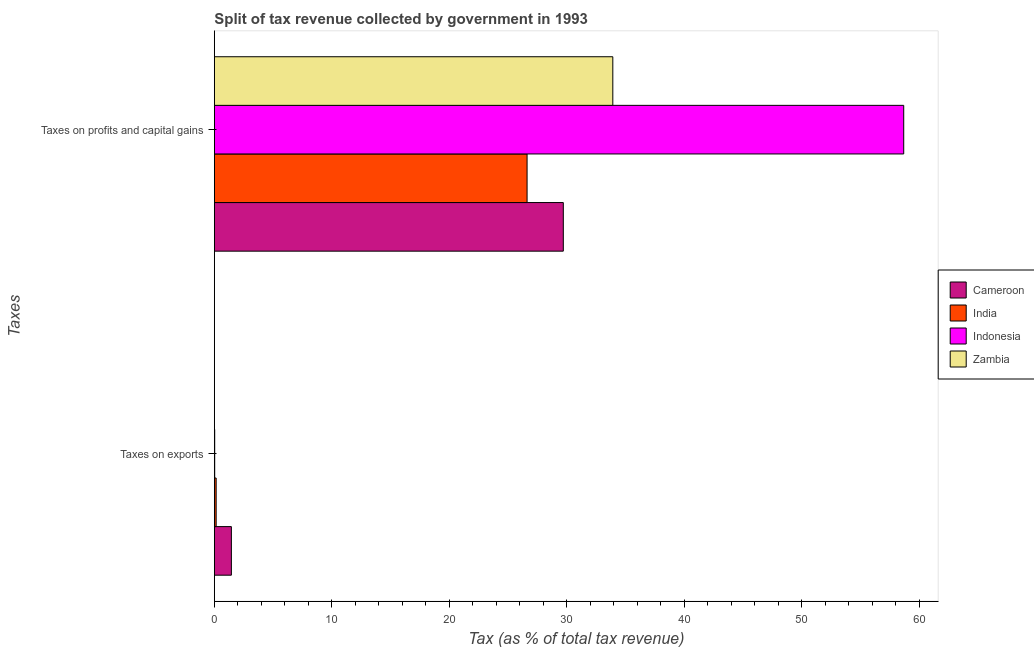How many different coloured bars are there?
Offer a terse response. 4. How many groups of bars are there?
Ensure brevity in your answer.  2. Are the number of bars per tick equal to the number of legend labels?
Make the answer very short. Yes. How many bars are there on the 2nd tick from the bottom?
Give a very brief answer. 4. What is the label of the 1st group of bars from the top?
Provide a succinct answer. Taxes on profits and capital gains. What is the percentage of revenue obtained from taxes on exports in India?
Your answer should be very brief. 0.15. Across all countries, what is the maximum percentage of revenue obtained from taxes on profits and capital gains?
Ensure brevity in your answer.  58.68. Across all countries, what is the minimum percentage of revenue obtained from taxes on profits and capital gains?
Your answer should be compact. 26.62. In which country was the percentage of revenue obtained from taxes on exports maximum?
Your response must be concise. Cameroon. What is the total percentage of revenue obtained from taxes on exports in the graph?
Ensure brevity in your answer.  1.64. What is the difference between the percentage of revenue obtained from taxes on profits and capital gains in India and that in Indonesia?
Make the answer very short. -32.06. What is the difference between the percentage of revenue obtained from taxes on profits and capital gains in India and the percentage of revenue obtained from taxes on exports in Zambia?
Your answer should be very brief. 26.61. What is the average percentage of revenue obtained from taxes on profits and capital gains per country?
Make the answer very short. 37.23. What is the difference between the percentage of revenue obtained from taxes on profits and capital gains and percentage of revenue obtained from taxes on exports in Zambia?
Your answer should be very brief. 33.91. What is the ratio of the percentage of revenue obtained from taxes on exports in Cameroon to that in India?
Make the answer very short. 9.42. Is the percentage of revenue obtained from taxes on exports in Cameroon less than that in Zambia?
Offer a very short reply. No. In how many countries, is the percentage of revenue obtained from taxes on exports greater than the average percentage of revenue obtained from taxes on exports taken over all countries?
Make the answer very short. 1. How many bars are there?
Ensure brevity in your answer.  8. What is the difference between two consecutive major ticks on the X-axis?
Offer a terse response. 10. Does the graph contain grids?
Make the answer very short. No. How many legend labels are there?
Make the answer very short. 4. How are the legend labels stacked?
Your answer should be compact. Vertical. What is the title of the graph?
Ensure brevity in your answer.  Split of tax revenue collected by government in 1993. What is the label or title of the X-axis?
Offer a very short reply. Tax (as % of total tax revenue). What is the label or title of the Y-axis?
Keep it short and to the point. Taxes. What is the Tax (as % of total tax revenue) of Cameroon in Taxes on exports?
Offer a very short reply. 1.45. What is the Tax (as % of total tax revenue) in India in Taxes on exports?
Offer a terse response. 0.15. What is the Tax (as % of total tax revenue) of Indonesia in Taxes on exports?
Your response must be concise. 0.03. What is the Tax (as % of total tax revenue) of Zambia in Taxes on exports?
Offer a very short reply. 0.01. What is the Tax (as % of total tax revenue) of Cameroon in Taxes on profits and capital gains?
Keep it short and to the point. 29.7. What is the Tax (as % of total tax revenue) of India in Taxes on profits and capital gains?
Your answer should be compact. 26.62. What is the Tax (as % of total tax revenue) of Indonesia in Taxes on profits and capital gains?
Provide a succinct answer. 58.68. What is the Tax (as % of total tax revenue) in Zambia in Taxes on profits and capital gains?
Your answer should be compact. 33.92. Across all Taxes, what is the maximum Tax (as % of total tax revenue) of Cameroon?
Make the answer very short. 29.7. Across all Taxes, what is the maximum Tax (as % of total tax revenue) of India?
Ensure brevity in your answer.  26.62. Across all Taxes, what is the maximum Tax (as % of total tax revenue) in Indonesia?
Your answer should be compact. 58.68. Across all Taxes, what is the maximum Tax (as % of total tax revenue) in Zambia?
Make the answer very short. 33.92. Across all Taxes, what is the minimum Tax (as % of total tax revenue) in Cameroon?
Provide a short and direct response. 1.45. Across all Taxes, what is the minimum Tax (as % of total tax revenue) in India?
Ensure brevity in your answer.  0.15. Across all Taxes, what is the minimum Tax (as % of total tax revenue) of Indonesia?
Provide a succinct answer. 0.03. Across all Taxes, what is the minimum Tax (as % of total tax revenue) of Zambia?
Offer a very short reply. 0.01. What is the total Tax (as % of total tax revenue) of Cameroon in the graph?
Provide a succinct answer. 31.15. What is the total Tax (as % of total tax revenue) in India in the graph?
Give a very brief answer. 26.77. What is the total Tax (as % of total tax revenue) in Indonesia in the graph?
Keep it short and to the point. 58.71. What is the total Tax (as % of total tax revenue) of Zambia in the graph?
Make the answer very short. 33.92. What is the difference between the Tax (as % of total tax revenue) of Cameroon in Taxes on exports and that in Taxes on profits and capital gains?
Provide a short and direct response. -28.25. What is the difference between the Tax (as % of total tax revenue) of India in Taxes on exports and that in Taxes on profits and capital gains?
Keep it short and to the point. -26.47. What is the difference between the Tax (as % of total tax revenue) in Indonesia in Taxes on exports and that in Taxes on profits and capital gains?
Give a very brief answer. -58.65. What is the difference between the Tax (as % of total tax revenue) of Zambia in Taxes on exports and that in Taxes on profits and capital gains?
Your answer should be very brief. -33.91. What is the difference between the Tax (as % of total tax revenue) in Cameroon in Taxes on exports and the Tax (as % of total tax revenue) in India in Taxes on profits and capital gains?
Provide a succinct answer. -25.17. What is the difference between the Tax (as % of total tax revenue) of Cameroon in Taxes on exports and the Tax (as % of total tax revenue) of Indonesia in Taxes on profits and capital gains?
Make the answer very short. -57.23. What is the difference between the Tax (as % of total tax revenue) in Cameroon in Taxes on exports and the Tax (as % of total tax revenue) in Zambia in Taxes on profits and capital gains?
Give a very brief answer. -32.47. What is the difference between the Tax (as % of total tax revenue) of India in Taxes on exports and the Tax (as % of total tax revenue) of Indonesia in Taxes on profits and capital gains?
Your answer should be compact. -58.53. What is the difference between the Tax (as % of total tax revenue) of India in Taxes on exports and the Tax (as % of total tax revenue) of Zambia in Taxes on profits and capital gains?
Your answer should be compact. -33.76. What is the difference between the Tax (as % of total tax revenue) of Indonesia in Taxes on exports and the Tax (as % of total tax revenue) of Zambia in Taxes on profits and capital gains?
Give a very brief answer. -33.89. What is the average Tax (as % of total tax revenue) in Cameroon per Taxes?
Offer a very short reply. 15.58. What is the average Tax (as % of total tax revenue) in India per Taxes?
Your answer should be very brief. 13.39. What is the average Tax (as % of total tax revenue) of Indonesia per Taxes?
Offer a terse response. 29.35. What is the average Tax (as % of total tax revenue) of Zambia per Taxes?
Offer a terse response. 16.96. What is the difference between the Tax (as % of total tax revenue) in Cameroon and Tax (as % of total tax revenue) in India in Taxes on exports?
Your answer should be very brief. 1.3. What is the difference between the Tax (as % of total tax revenue) of Cameroon and Tax (as % of total tax revenue) of Indonesia in Taxes on exports?
Offer a terse response. 1.42. What is the difference between the Tax (as % of total tax revenue) of Cameroon and Tax (as % of total tax revenue) of Zambia in Taxes on exports?
Make the answer very short. 1.44. What is the difference between the Tax (as % of total tax revenue) of India and Tax (as % of total tax revenue) of Indonesia in Taxes on exports?
Your answer should be very brief. 0.12. What is the difference between the Tax (as % of total tax revenue) of India and Tax (as % of total tax revenue) of Zambia in Taxes on exports?
Keep it short and to the point. 0.15. What is the difference between the Tax (as % of total tax revenue) of Indonesia and Tax (as % of total tax revenue) of Zambia in Taxes on exports?
Offer a very short reply. 0.02. What is the difference between the Tax (as % of total tax revenue) in Cameroon and Tax (as % of total tax revenue) in India in Taxes on profits and capital gains?
Give a very brief answer. 3.08. What is the difference between the Tax (as % of total tax revenue) in Cameroon and Tax (as % of total tax revenue) in Indonesia in Taxes on profits and capital gains?
Keep it short and to the point. -28.98. What is the difference between the Tax (as % of total tax revenue) of Cameroon and Tax (as % of total tax revenue) of Zambia in Taxes on profits and capital gains?
Provide a succinct answer. -4.21. What is the difference between the Tax (as % of total tax revenue) in India and Tax (as % of total tax revenue) in Indonesia in Taxes on profits and capital gains?
Your response must be concise. -32.06. What is the difference between the Tax (as % of total tax revenue) in India and Tax (as % of total tax revenue) in Zambia in Taxes on profits and capital gains?
Your answer should be very brief. -7.3. What is the difference between the Tax (as % of total tax revenue) of Indonesia and Tax (as % of total tax revenue) of Zambia in Taxes on profits and capital gains?
Your response must be concise. 24.76. What is the ratio of the Tax (as % of total tax revenue) of Cameroon in Taxes on exports to that in Taxes on profits and capital gains?
Offer a terse response. 0.05. What is the ratio of the Tax (as % of total tax revenue) of India in Taxes on exports to that in Taxes on profits and capital gains?
Make the answer very short. 0.01. What is the ratio of the Tax (as % of total tax revenue) of Zambia in Taxes on exports to that in Taxes on profits and capital gains?
Provide a succinct answer. 0. What is the difference between the highest and the second highest Tax (as % of total tax revenue) in Cameroon?
Provide a short and direct response. 28.25. What is the difference between the highest and the second highest Tax (as % of total tax revenue) of India?
Give a very brief answer. 26.47. What is the difference between the highest and the second highest Tax (as % of total tax revenue) in Indonesia?
Offer a very short reply. 58.65. What is the difference between the highest and the second highest Tax (as % of total tax revenue) in Zambia?
Give a very brief answer. 33.91. What is the difference between the highest and the lowest Tax (as % of total tax revenue) in Cameroon?
Provide a short and direct response. 28.25. What is the difference between the highest and the lowest Tax (as % of total tax revenue) of India?
Your response must be concise. 26.47. What is the difference between the highest and the lowest Tax (as % of total tax revenue) of Indonesia?
Your answer should be very brief. 58.65. What is the difference between the highest and the lowest Tax (as % of total tax revenue) in Zambia?
Offer a terse response. 33.91. 